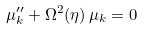<formula> <loc_0><loc_0><loc_500><loc_500>\mu _ { k } ^ { \prime \prime } + \Omega ^ { 2 } ( \eta ) \, \mu _ { k } = 0</formula> 